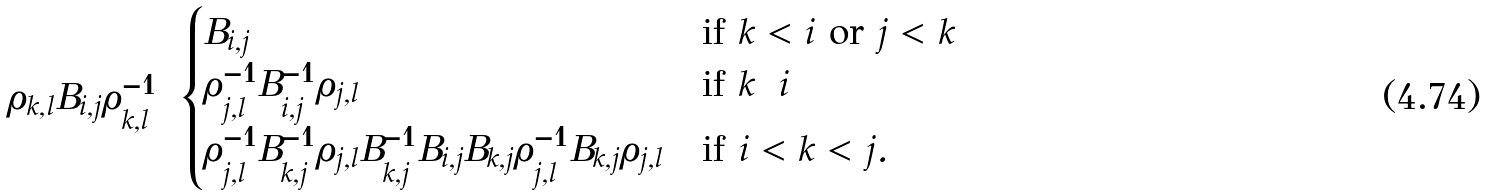Convert formula to latex. <formula><loc_0><loc_0><loc_500><loc_500>\rho _ { k , l } B _ { i , j } \rho _ { k , l } ^ { - 1 } = \begin{cases} B _ { i , j } & \text {if $k<i$ or $j<k$} \\ \rho _ { j , l } ^ { - 1 } B _ { i , j } ^ { - 1 } \rho _ { j , l } & \text {if $k=i$} \\ \rho _ { j , l } ^ { - 1 } B _ { k , j } ^ { - 1 } \rho _ { j , l } B _ { k , j } ^ { - 1 } B _ { i , j } B _ { k , j } \rho _ { j , l } ^ { - 1 } B _ { k , j } \rho _ { j , l } & \text {if $i<k<j$} . \end{cases}</formula> 